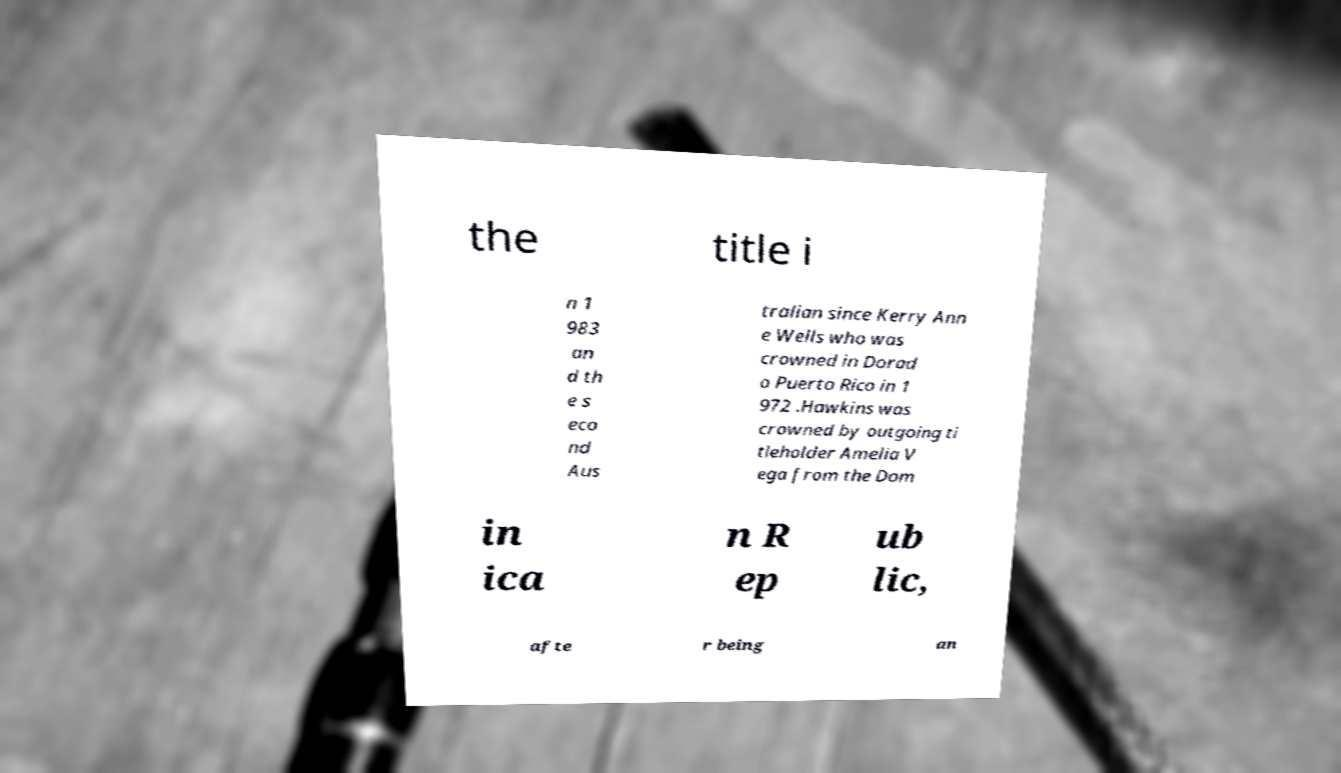For documentation purposes, I need the text within this image transcribed. Could you provide that? the title i n 1 983 an d th e s eco nd Aus tralian since Kerry Ann e Wells who was crowned in Dorad o Puerto Rico in 1 972 .Hawkins was crowned by outgoing ti tleholder Amelia V ega from the Dom in ica n R ep ub lic, afte r being an 